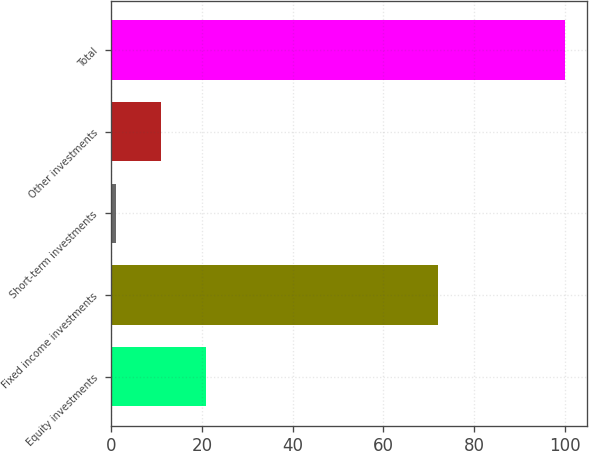Convert chart. <chart><loc_0><loc_0><loc_500><loc_500><bar_chart><fcel>Equity investments<fcel>Fixed income investments<fcel>Short-term investments<fcel>Other investments<fcel>Total<nl><fcel>20.8<fcel>72<fcel>1<fcel>10.9<fcel>100<nl></chart> 